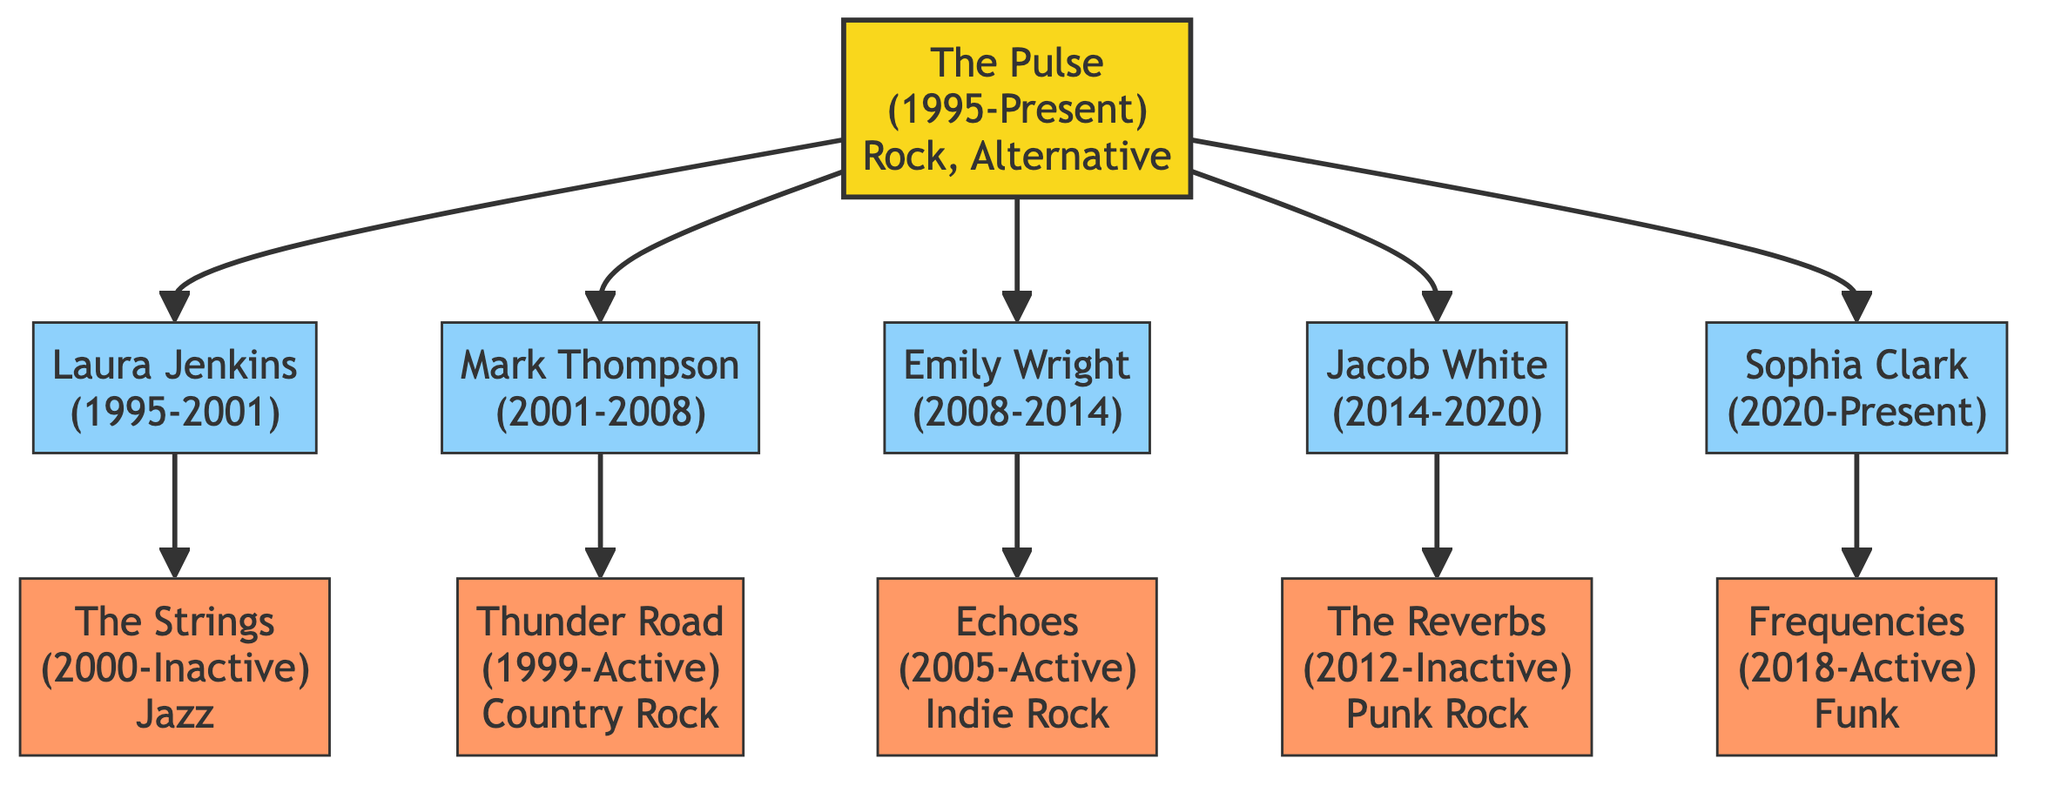What is the name of the current bassist for The Pulse? The diagram shows that Sophia Clark is the current bassist for The Pulse, indicated by her status noted in parentheses.
Answer: Sophia Clark In what year did Laura Jenkins leave The Pulse? The diagram specifies that Laura Jenkins left The Pulse in 2001, which is noted directly beside her name in the diagram.
Answer: 2001 How many bassists have been part of The Pulse? Counting the bassists listed in the diagram, there are five individuals shown as having been part of The Pulse: Laura Jenkins, Mark Thompson, Emily Wright, Jacob White, and Sophia Clark.
Answer: 5 What reason did Mark Thompson have for leaving The Pulse? The diagram explicitly states that Mark Thompson left The Pulse due to "Family Commitments," which is detailed in the node connected to him.
Answer: Family Commitments Which band was Laura Jenkins part of after leaving The Pulse? According to the diagram, Laura Jenkins joined "The Strings" after her time with The Pulse, as indicated in the related bands section connected to her node.
Answer: The Strings Which bassist had the longest tenure in The Pulse? By examining the years each bassist was with The Pulse, Emily Wright had a six-year tenure (2008-2014), which is the longest among the bassists listed.
Answer: Emily Wright What genre is associated with the band Thunder Road? The diagram indicates that Thunder Road is associated with the genre "Country Rock," which is specified next to the band in the diagram.
Answer: Country Rock How many bassists left The Pulse due to personal reasons? By reviewing the information in the diagram, both Mark Thompson (Family Commitments) and Jacob White (Health Issues) left The Pulse for personal reasons, totaling two bassists.
Answer: 2 Which band is currently active that Sophia Clark is associated with? The diagram highlights that Sophia Clark is associated with the band "Frequencies," which is indicated as currently active.
Answer: Frequencies 